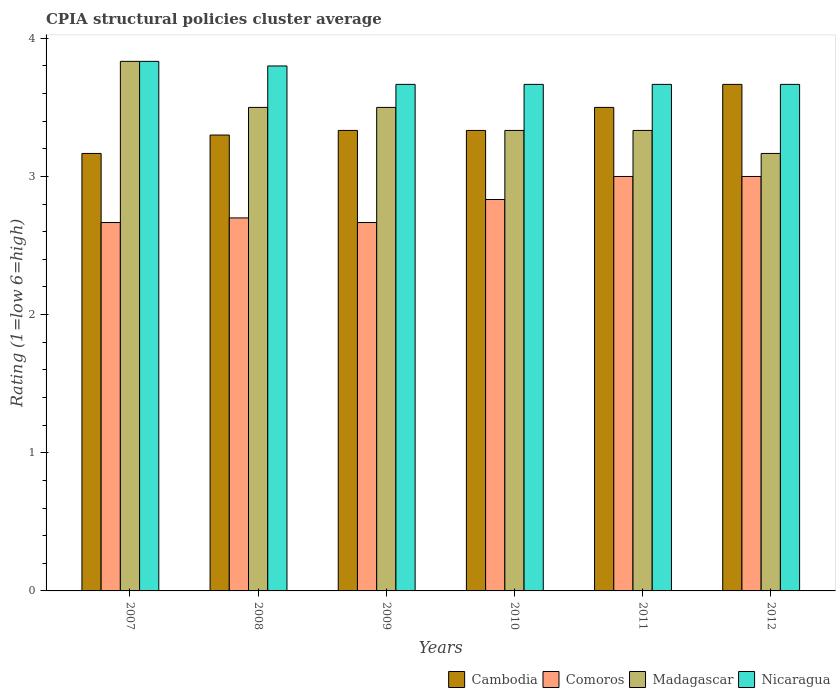How many different coloured bars are there?
Provide a succinct answer. 4. How many groups of bars are there?
Your answer should be compact. 6. Are the number of bars on each tick of the X-axis equal?
Your response must be concise. Yes. How many bars are there on the 6th tick from the left?
Provide a short and direct response. 4. What is the CPIA rating in Comoros in 2008?
Your response must be concise. 2.7. Across all years, what is the maximum CPIA rating in Cambodia?
Provide a succinct answer. 3.67. Across all years, what is the minimum CPIA rating in Nicaragua?
Provide a succinct answer. 3.67. In which year was the CPIA rating in Cambodia minimum?
Ensure brevity in your answer.  2007. What is the total CPIA rating in Nicaragua in the graph?
Offer a very short reply. 22.3. What is the difference between the CPIA rating in Cambodia in 2007 and that in 2010?
Offer a terse response. -0.17. What is the difference between the CPIA rating in Cambodia in 2011 and the CPIA rating in Madagascar in 2007?
Make the answer very short. -0.33. What is the average CPIA rating in Nicaragua per year?
Give a very brief answer. 3.72. In the year 2008, what is the difference between the CPIA rating in Madagascar and CPIA rating in Nicaragua?
Keep it short and to the point. -0.3. What is the ratio of the CPIA rating in Madagascar in 2009 to that in 2011?
Provide a short and direct response. 1.05. Is the CPIA rating in Comoros in 2008 less than that in 2012?
Offer a very short reply. Yes. In how many years, is the CPIA rating in Madagascar greater than the average CPIA rating in Madagascar taken over all years?
Provide a succinct answer. 3. Is it the case that in every year, the sum of the CPIA rating in Cambodia and CPIA rating in Nicaragua is greater than the sum of CPIA rating in Comoros and CPIA rating in Madagascar?
Your answer should be compact. No. What does the 1st bar from the left in 2008 represents?
Your response must be concise. Cambodia. What does the 3rd bar from the right in 2011 represents?
Offer a very short reply. Comoros. Are all the bars in the graph horizontal?
Offer a terse response. No. How many years are there in the graph?
Provide a succinct answer. 6. What is the difference between two consecutive major ticks on the Y-axis?
Keep it short and to the point. 1. Are the values on the major ticks of Y-axis written in scientific E-notation?
Offer a terse response. No. Does the graph contain any zero values?
Provide a succinct answer. No. Does the graph contain grids?
Your answer should be very brief. No. What is the title of the graph?
Provide a short and direct response. CPIA structural policies cluster average. Does "Comoros" appear as one of the legend labels in the graph?
Make the answer very short. Yes. What is the Rating (1=low 6=high) in Cambodia in 2007?
Your answer should be compact. 3.17. What is the Rating (1=low 6=high) of Comoros in 2007?
Keep it short and to the point. 2.67. What is the Rating (1=low 6=high) of Madagascar in 2007?
Keep it short and to the point. 3.83. What is the Rating (1=low 6=high) in Nicaragua in 2007?
Your answer should be compact. 3.83. What is the Rating (1=low 6=high) in Cambodia in 2008?
Your answer should be compact. 3.3. What is the Rating (1=low 6=high) of Comoros in 2008?
Your response must be concise. 2.7. What is the Rating (1=low 6=high) of Nicaragua in 2008?
Offer a terse response. 3.8. What is the Rating (1=low 6=high) of Cambodia in 2009?
Ensure brevity in your answer.  3.33. What is the Rating (1=low 6=high) of Comoros in 2009?
Offer a very short reply. 2.67. What is the Rating (1=low 6=high) of Nicaragua in 2009?
Ensure brevity in your answer.  3.67. What is the Rating (1=low 6=high) of Cambodia in 2010?
Your response must be concise. 3.33. What is the Rating (1=low 6=high) in Comoros in 2010?
Offer a terse response. 2.83. What is the Rating (1=low 6=high) of Madagascar in 2010?
Give a very brief answer. 3.33. What is the Rating (1=low 6=high) in Nicaragua in 2010?
Keep it short and to the point. 3.67. What is the Rating (1=low 6=high) in Madagascar in 2011?
Provide a succinct answer. 3.33. What is the Rating (1=low 6=high) of Nicaragua in 2011?
Keep it short and to the point. 3.67. What is the Rating (1=low 6=high) in Cambodia in 2012?
Provide a succinct answer. 3.67. What is the Rating (1=low 6=high) of Comoros in 2012?
Your response must be concise. 3. What is the Rating (1=low 6=high) of Madagascar in 2012?
Provide a short and direct response. 3.17. What is the Rating (1=low 6=high) in Nicaragua in 2012?
Keep it short and to the point. 3.67. Across all years, what is the maximum Rating (1=low 6=high) of Cambodia?
Make the answer very short. 3.67. Across all years, what is the maximum Rating (1=low 6=high) in Madagascar?
Provide a succinct answer. 3.83. Across all years, what is the maximum Rating (1=low 6=high) in Nicaragua?
Your response must be concise. 3.83. Across all years, what is the minimum Rating (1=low 6=high) of Cambodia?
Your answer should be compact. 3.17. Across all years, what is the minimum Rating (1=low 6=high) of Comoros?
Keep it short and to the point. 2.67. Across all years, what is the minimum Rating (1=low 6=high) in Madagascar?
Provide a succinct answer. 3.17. Across all years, what is the minimum Rating (1=low 6=high) in Nicaragua?
Offer a very short reply. 3.67. What is the total Rating (1=low 6=high) in Cambodia in the graph?
Give a very brief answer. 20.3. What is the total Rating (1=low 6=high) of Comoros in the graph?
Give a very brief answer. 16.87. What is the total Rating (1=low 6=high) in Madagascar in the graph?
Provide a short and direct response. 20.67. What is the total Rating (1=low 6=high) of Nicaragua in the graph?
Give a very brief answer. 22.3. What is the difference between the Rating (1=low 6=high) in Cambodia in 2007 and that in 2008?
Your response must be concise. -0.13. What is the difference between the Rating (1=low 6=high) in Comoros in 2007 and that in 2008?
Offer a very short reply. -0.03. What is the difference between the Rating (1=low 6=high) in Nicaragua in 2007 and that in 2008?
Make the answer very short. 0.03. What is the difference between the Rating (1=low 6=high) in Comoros in 2007 and that in 2009?
Offer a terse response. 0. What is the difference between the Rating (1=low 6=high) in Cambodia in 2007 and that in 2011?
Offer a very short reply. -0.33. What is the difference between the Rating (1=low 6=high) of Nicaragua in 2007 and that in 2011?
Offer a terse response. 0.17. What is the difference between the Rating (1=low 6=high) in Comoros in 2007 and that in 2012?
Your answer should be very brief. -0.33. What is the difference between the Rating (1=low 6=high) in Madagascar in 2007 and that in 2012?
Offer a terse response. 0.67. What is the difference between the Rating (1=low 6=high) in Nicaragua in 2007 and that in 2012?
Your answer should be compact. 0.17. What is the difference between the Rating (1=low 6=high) of Cambodia in 2008 and that in 2009?
Give a very brief answer. -0.03. What is the difference between the Rating (1=low 6=high) in Madagascar in 2008 and that in 2009?
Your answer should be very brief. 0. What is the difference between the Rating (1=low 6=high) in Nicaragua in 2008 and that in 2009?
Offer a terse response. 0.13. What is the difference between the Rating (1=low 6=high) in Cambodia in 2008 and that in 2010?
Make the answer very short. -0.03. What is the difference between the Rating (1=low 6=high) in Comoros in 2008 and that in 2010?
Provide a succinct answer. -0.13. What is the difference between the Rating (1=low 6=high) in Nicaragua in 2008 and that in 2010?
Offer a terse response. 0.13. What is the difference between the Rating (1=low 6=high) in Madagascar in 2008 and that in 2011?
Provide a succinct answer. 0.17. What is the difference between the Rating (1=low 6=high) in Nicaragua in 2008 and that in 2011?
Your answer should be compact. 0.13. What is the difference between the Rating (1=low 6=high) in Cambodia in 2008 and that in 2012?
Offer a very short reply. -0.37. What is the difference between the Rating (1=low 6=high) of Comoros in 2008 and that in 2012?
Provide a short and direct response. -0.3. What is the difference between the Rating (1=low 6=high) of Nicaragua in 2008 and that in 2012?
Your answer should be very brief. 0.13. What is the difference between the Rating (1=low 6=high) of Nicaragua in 2009 and that in 2010?
Your response must be concise. 0. What is the difference between the Rating (1=low 6=high) in Nicaragua in 2009 and that in 2011?
Ensure brevity in your answer.  0. What is the difference between the Rating (1=low 6=high) in Cambodia in 2009 and that in 2012?
Keep it short and to the point. -0.33. What is the difference between the Rating (1=low 6=high) in Comoros in 2009 and that in 2012?
Your answer should be very brief. -0.33. What is the difference between the Rating (1=low 6=high) of Madagascar in 2009 and that in 2012?
Offer a terse response. 0.33. What is the difference between the Rating (1=low 6=high) of Nicaragua in 2009 and that in 2012?
Ensure brevity in your answer.  0. What is the difference between the Rating (1=low 6=high) in Comoros in 2010 and that in 2011?
Provide a short and direct response. -0.17. What is the difference between the Rating (1=low 6=high) in Nicaragua in 2010 and that in 2011?
Offer a very short reply. 0. What is the difference between the Rating (1=low 6=high) of Cambodia in 2010 and that in 2012?
Provide a short and direct response. -0.33. What is the difference between the Rating (1=low 6=high) of Comoros in 2010 and that in 2012?
Provide a short and direct response. -0.17. What is the difference between the Rating (1=low 6=high) of Cambodia in 2011 and that in 2012?
Offer a very short reply. -0.17. What is the difference between the Rating (1=low 6=high) of Comoros in 2011 and that in 2012?
Provide a succinct answer. 0. What is the difference between the Rating (1=low 6=high) of Cambodia in 2007 and the Rating (1=low 6=high) of Comoros in 2008?
Provide a succinct answer. 0.47. What is the difference between the Rating (1=low 6=high) of Cambodia in 2007 and the Rating (1=low 6=high) of Nicaragua in 2008?
Your answer should be compact. -0.63. What is the difference between the Rating (1=low 6=high) in Comoros in 2007 and the Rating (1=low 6=high) in Nicaragua in 2008?
Give a very brief answer. -1.13. What is the difference between the Rating (1=low 6=high) in Madagascar in 2007 and the Rating (1=low 6=high) in Nicaragua in 2008?
Give a very brief answer. 0.03. What is the difference between the Rating (1=low 6=high) in Cambodia in 2007 and the Rating (1=low 6=high) in Comoros in 2009?
Offer a very short reply. 0.5. What is the difference between the Rating (1=low 6=high) of Cambodia in 2007 and the Rating (1=low 6=high) of Madagascar in 2009?
Ensure brevity in your answer.  -0.33. What is the difference between the Rating (1=low 6=high) of Cambodia in 2007 and the Rating (1=low 6=high) of Nicaragua in 2009?
Offer a terse response. -0.5. What is the difference between the Rating (1=low 6=high) in Madagascar in 2007 and the Rating (1=low 6=high) in Nicaragua in 2009?
Your answer should be very brief. 0.17. What is the difference between the Rating (1=low 6=high) in Cambodia in 2007 and the Rating (1=low 6=high) in Nicaragua in 2010?
Provide a short and direct response. -0.5. What is the difference between the Rating (1=low 6=high) in Comoros in 2007 and the Rating (1=low 6=high) in Madagascar in 2010?
Your response must be concise. -0.67. What is the difference between the Rating (1=low 6=high) of Comoros in 2007 and the Rating (1=low 6=high) of Nicaragua in 2010?
Offer a terse response. -1. What is the difference between the Rating (1=low 6=high) of Cambodia in 2007 and the Rating (1=low 6=high) of Nicaragua in 2011?
Your answer should be very brief. -0.5. What is the difference between the Rating (1=low 6=high) in Comoros in 2007 and the Rating (1=low 6=high) in Madagascar in 2011?
Offer a very short reply. -0.67. What is the difference between the Rating (1=low 6=high) in Cambodia in 2007 and the Rating (1=low 6=high) in Nicaragua in 2012?
Provide a succinct answer. -0.5. What is the difference between the Rating (1=low 6=high) in Comoros in 2007 and the Rating (1=low 6=high) in Nicaragua in 2012?
Your answer should be compact. -1. What is the difference between the Rating (1=low 6=high) of Cambodia in 2008 and the Rating (1=low 6=high) of Comoros in 2009?
Make the answer very short. 0.63. What is the difference between the Rating (1=low 6=high) of Cambodia in 2008 and the Rating (1=low 6=high) of Nicaragua in 2009?
Offer a very short reply. -0.37. What is the difference between the Rating (1=low 6=high) of Comoros in 2008 and the Rating (1=low 6=high) of Nicaragua in 2009?
Give a very brief answer. -0.97. What is the difference between the Rating (1=low 6=high) of Madagascar in 2008 and the Rating (1=low 6=high) of Nicaragua in 2009?
Your answer should be very brief. -0.17. What is the difference between the Rating (1=low 6=high) in Cambodia in 2008 and the Rating (1=low 6=high) in Comoros in 2010?
Your answer should be compact. 0.47. What is the difference between the Rating (1=low 6=high) of Cambodia in 2008 and the Rating (1=low 6=high) of Madagascar in 2010?
Your answer should be compact. -0.03. What is the difference between the Rating (1=low 6=high) in Cambodia in 2008 and the Rating (1=low 6=high) in Nicaragua in 2010?
Offer a terse response. -0.37. What is the difference between the Rating (1=low 6=high) of Comoros in 2008 and the Rating (1=low 6=high) of Madagascar in 2010?
Provide a short and direct response. -0.63. What is the difference between the Rating (1=low 6=high) of Comoros in 2008 and the Rating (1=low 6=high) of Nicaragua in 2010?
Provide a succinct answer. -0.97. What is the difference between the Rating (1=low 6=high) in Madagascar in 2008 and the Rating (1=low 6=high) in Nicaragua in 2010?
Provide a succinct answer. -0.17. What is the difference between the Rating (1=low 6=high) of Cambodia in 2008 and the Rating (1=low 6=high) of Madagascar in 2011?
Your answer should be very brief. -0.03. What is the difference between the Rating (1=low 6=high) in Cambodia in 2008 and the Rating (1=low 6=high) in Nicaragua in 2011?
Provide a succinct answer. -0.37. What is the difference between the Rating (1=low 6=high) in Comoros in 2008 and the Rating (1=low 6=high) in Madagascar in 2011?
Your response must be concise. -0.63. What is the difference between the Rating (1=low 6=high) of Comoros in 2008 and the Rating (1=low 6=high) of Nicaragua in 2011?
Ensure brevity in your answer.  -0.97. What is the difference between the Rating (1=low 6=high) of Madagascar in 2008 and the Rating (1=low 6=high) of Nicaragua in 2011?
Your answer should be very brief. -0.17. What is the difference between the Rating (1=low 6=high) in Cambodia in 2008 and the Rating (1=low 6=high) in Comoros in 2012?
Offer a terse response. 0.3. What is the difference between the Rating (1=low 6=high) in Cambodia in 2008 and the Rating (1=low 6=high) in Madagascar in 2012?
Your response must be concise. 0.13. What is the difference between the Rating (1=low 6=high) in Cambodia in 2008 and the Rating (1=low 6=high) in Nicaragua in 2012?
Provide a succinct answer. -0.37. What is the difference between the Rating (1=low 6=high) in Comoros in 2008 and the Rating (1=low 6=high) in Madagascar in 2012?
Keep it short and to the point. -0.47. What is the difference between the Rating (1=low 6=high) in Comoros in 2008 and the Rating (1=low 6=high) in Nicaragua in 2012?
Your answer should be very brief. -0.97. What is the difference between the Rating (1=low 6=high) of Madagascar in 2008 and the Rating (1=low 6=high) of Nicaragua in 2012?
Provide a succinct answer. -0.17. What is the difference between the Rating (1=low 6=high) in Cambodia in 2009 and the Rating (1=low 6=high) in Comoros in 2010?
Ensure brevity in your answer.  0.5. What is the difference between the Rating (1=low 6=high) of Comoros in 2009 and the Rating (1=low 6=high) of Nicaragua in 2010?
Offer a terse response. -1. What is the difference between the Rating (1=low 6=high) of Madagascar in 2009 and the Rating (1=low 6=high) of Nicaragua in 2010?
Ensure brevity in your answer.  -0.17. What is the difference between the Rating (1=low 6=high) in Cambodia in 2009 and the Rating (1=low 6=high) in Comoros in 2011?
Make the answer very short. 0.33. What is the difference between the Rating (1=low 6=high) in Cambodia in 2009 and the Rating (1=low 6=high) in Nicaragua in 2011?
Ensure brevity in your answer.  -0.33. What is the difference between the Rating (1=low 6=high) in Comoros in 2009 and the Rating (1=low 6=high) in Madagascar in 2011?
Provide a short and direct response. -0.67. What is the difference between the Rating (1=low 6=high) in Comoros in 2009 and the Rating (1=low 6=high) in Nicaragua in 2011?
Offer a very short reply. -1. What is the difference between the Rating (1=low 6=high) in Cambodia in 2009 and the Rating (1=low 6=high) in Comoros in 2012?
Make the answer very short. 0.33. What is the difference between the Rating (1=low 6=high) in Cambodia in 2009 and the Rating (1=low 6=high) in Nicaragua in 2012?
Ensure brevity in your answer.  -0.33. What is the difference between the Rating (1=low 6=high) in Cambodia in 2010 and the Rating (1=low 6=high) in Nicaragua in 2011?
Your answer should be compact. -0.33. What is the difference between the Rating (1=low 6=high) of Comoros in 2010 and the Rating (1=low 6=high) of Madagascar in 2011?
Keep it short and to the point. -0.5. What is the difference between the Rating (1=low 6=high) in Comoros in 2010 and the Rating (1=low 6=high) in Nicaragua in 2011?
Your answer should be compact. -0.83. What is the difference between the Rating (1=low 6=high) of Cambodia in 2010 and the Rating (1=low 6=high) of Madagascar in 2012?
Your answer should be very brief. 0.17. What is the difference between the Rating (1=low 6=high) in Comoros in 2010 and the Rating (1=low 6=high) in Madagascar in 2012?
Give a very brief answer. -0.33. What is the difference between the Rating (1=low 6=high) of Comoros in 2010 and the Rating (1=low 6=high) of Nicaragua in 2012?
Keep it short and to the point. -0.83. What is the difference between the Rating (1=low 6=high) of Cambodia in 2011 and the Rating (1=low 6=high) of Madagascar in 2012?
Provide a succinct answer. 0.33. What is the difference between the Rating (1=low 6=high) of Cambodia in 2011 and the Rating (1=low 6=high) of Nicaragua in 2012?
Keep it short and to the point. -0.17. What is the difference between the Rating (1=low 6=high) of Comoros in 2011 and the Rating (1=low 6=high) of Madagascar in 2012?
Make the answer very short. -0.17. What is the difference between the Rating (1=low 6=high) of Comoros in 2011 and the Rating (1=low 6=high) of Nicaragua in 2012?
Offer a very short reply. -0.67. What is the difference between the Rating (1=low 6=high) in Madagascar in 2011 and the Rating (1=low 6=high) in Nicaragua in 2012?
Offer a very short reply. -0.33. What is the average Rating (1=low 6=high) of Cambodia per year?
Give a very brief answer. 3.38. What is the average Rating (1=low 6=high) of Comoros per year?
Give a very brief answer. 2.81. What is the average Rating (1=low 6=high) in Madagascar per year?
Offer a terse response. 3.44. What is the average Rating (1=low 6=high) of Nicaragua per year?
Provide a succinct answer. 3.72. In the year 2007, what is the difference between the Rating (1=low 6=high) of Cambodia and Rating (1=low 6=high) of Comoros?
Offer a very short reply. 0.5. In the year 2007, what is the difference between the Rating (1=low 6=high) in Cambodia and Rating (1=low 6=high) in Madagascar?
Ensure brevity in your answer.  -0.67. In the year 2007, what is the difference between the Rating (1=low 6=high) of Comoros and Rating (1=low 6=high) of Madagascar?
Your response must be concise. -1.17. In the year 2007, what is the difference between the Rating (1=low 6=high) of Comoros and Rating (1=low 6=high) of Nicaragua?
Offer a very short reply. -1.17. In the year 2008, what is the difference between the Rating (1=low 6=high) in Cambodia and Rating (1=low 6=high) in Comoros?
Your answer should be compact. 0.6. In the year 2008, what is the difference between the Rating (1=low 6=high) in Cambodia and Rating (1=low 6=high) in Madagascar?
Make the answer very short. -0.2. In the year 2008, what is the difference between the Rating (1=low 6=high) of Madagascar and Rating (1=low 6=high) of Nicaragua?
Make the answer very short. -0.3. In the year 2009, what is the difference between the Rating (1=low 6=high) of Cambodia and Rating (1=low 6=high) of Madagascar?
Keep it short and to the point. -0.17. In the year 2009, what is the difference between the Rating (1=low 6=high) of Comoros and Rating (1=low 6=high) of Madagascar?
Provide a short and direct response. -0.83. In the year 2010, what is the difference between the Rating (1=low 6=high) of Cambodia and Rating (1=low 6=high) of Comoros?
Provide a short and direct response. 0.5. In the year 2010, what is the difference between the Rating (1=low 6=high) in Cambodia and Rating (1=low 6=high) in Madagascar?
Ensure brevity in your answer.  0. In the year 2010, what is the difference between the Rating (1=low 6=high) of Cambodia and Rating (1=low 6=high) of Nicaragua?
Offer a very short reply. -0.33. In the year 2011, what is the difference between the Rating (1=low 6=high) of Cambodia and Rating (1=low 6=high) of Comoros?
Offer a terse response. 0.5. In the year 2011, what is the difference between the Rating (1=low 6=high) of Cambodia and Rating (1=low 6=high) of Madagascar?
Give a very brief answer. 0.17. In the year 2011, what is the difference between the Rating (1=low 6=high) in Comoros and Rating (1=low 6=high) in Madagascar?
Keep it short and to the point. -0.33. In the year 2011, what is the difference between the Rating (1=low 6=high) of Comoros and Rating (1=low 6=high) of Nicaragua?
Ensure brevity in your answer.  -0.67. In the year 2012, what is the difference between the Rating (1=low 6=high) in Cambodia and Rating (1=low 6=high) in Madagascar?
Offer a very short reply. 0.5. In the year 2012, what is the difference between the Rating (1=low 6=high) of Cambodia and Rating (1=low 6=high) of Nicaragua?
Offer a terse response. 0. What is the ratio of the Rating (1=low 6=high) in Cambodia in 2007 to that in 2008?
Your answer should be very brief. 0.96. What is the ratio of the Rating (1=low 6=high) in Comoros in 2007 to that in 2008?
Offer a terse response. 0.99. What is the ratio of the Rating (1=low 6=high) of Madagascar in 2007 to that in 2008?
Your response must be concise. 1.1. What is the ratio of the Rating (1=low 6=high) in Nicaragua in 2007 to that in 2008?
Offer a very short reply. 1.01. What is the ratio of the Rating (1=low 6=high) in Cambodia in 2007 to that in 2009?
Keep it short and to the point. 0.95. What is the ratio of the Rating (1=low 6=high) in Comoros in 2007 to that in 2009?
Your answer should be compact. 1. What is the ratio of the Rating (1=low 6=high) of Madagascar in 2007 to that in 2009?
Provide a short and direct response. 1.1. What is the ratio of the Rating (1=low 6=high) in Nicaragua in 2007 to that in 2009?
Give a very brief answer. 1.05. What is the ratio of the Rating (1=low 6=high) of Cambodia in 2007 to that in 2010?
Your response must be concise. 0.95. What is the ratio of the Rating (1=low 6=high) in Comoros in 2007 to that in 2010?
Ensure brevity in your answer.  0.94. What is the ratio of the Rating (1=low 6=high) in Madagascar in 2007 to that in 2010?
Make the answer very short. 1.15. What is the ratio of the Rating (1=low 6=high) of Nicaragua in 2007 to that in 2010?
Your answer should be very brief. 1.05. What is the ratio of the Rating (1=low 6=high) in Cambodia in 2007 to that in 2011?
Your answer should be compact. 0.9. What is the ratio of the Rating (1=low 6=high) of Madagascar in 2007 to that in 2011?
Keep it short and to the point. 1.15. What is the ratio of the Rating (1=low 6=high) in Nicaragua in 2007 to that in 2011?
Provide a succinct answer. 1.05. What is the ratio of the Rating (1=low 6=high) in Cambodia in 2007 to that in 2012?
Ensure brevity in your answer.  0.86. What is the ratio of the Rating (1=low 6=high) in Comoros in 2007 to that in 2012?
Keep it short and to the point. 0.89. What is the ratio of the Rating (1=low 6=high) in Madagascar in 2007 to that in 2012?
Keep it short and to the point. 1.21. What is the ratio of the Rating (1=low 6=high) in Nicaragua in 2007 to that in 2012?
Make the answer very short. 1.05. What is the ratio of the Rating (1=low 6=high) of Cambodia in 2008 to that in 2009?
Provide a succinct answer. 0.99. What is the ratio of the Rating (1=low 6=high) in Comoros in 2008 to that in 2009?
Your answer should be compact. 1.01. What is the ratio of the Rating (1=low 6=high) of Madagascar in 2008 to that in 2009?
Provide a short and direct response. 1. What is the ratio of the Rating (1=low 6=high) of Nicaragua in 2008 to that in 2009?
Give a very brief answer. 1.04. What is the ratio of the Rating (1=low 6=high) of Comoros in 2008 to that in 2010?
Ensure brevity in your answer.  0.95. What is the ratio of the Rating (1=low 6=high) in Nicaragua in 2008 to that in 2010?
Your answer should be compact. 1.04. What is the ratio of the Rating (1=low 6=high) in Cambodia in 2008 to that in 2011?
Your answer should be very brief. 0.94. What is the ratio of the Rating (1=low 6=high) in Comoros in 2008 to that in 2011?
Offer a terse response. 0.9. What is the ratio of the Rating (1=low 6=high) in Nicaragua in 2008 to that in 2011?
Make the answer very short. 1.04. What is the ratio of the Rating (1=low 6=high) of Madagascar in 2008 to that in 2012?
Provide a short and direct response. 1.11. What is the ratio of the Rating (1=low 6=high) of Nicaragua in 2008 to that in 2012?
Your answer should be compact. 1.04. What is the ratio of the Rating (1=low 6=high) in Nicaragua in 2009 to that in 2010?
Offer a very short reply. 1. What is the ratio of the Rating (1=low 6=high) in Cambodia in 2009 to that in 2011?
Keep it short and to the point. 0.95. What is the ratio of the Rating (1=low 6=high) in Comoros in 2009 to that in 2012?
Offer a terse response. 0.89. What is the ratio of the Rating (1=low 6=high) in Madagascar in 2009 to that in 2012?
Your answer should be compact. 1.11. What is the ratio of the Rating (1=low 6=high) of Nicaragua in 2009 to that in 2012?
Provide a succinct answer. 1. What is the ratio of the Rating (1=low 6=high) of Cambodia in 2010 to that in 2012?
Your answer should be compact. 0.91. What is the ratio of the Rating (1=low 6=high) of Madagascar in 2010 to that in 2012?
Keep it short and to the point. 1.05. What is the ratio of the Rating (1=low 6=high) of Cambodia in 2011 to that in 2012?
Your answer should be very brief. 0.95. What is the ratio of the Rating (1=low 6=high) in Comoros in 2011 to that in 2012?
Your response must be concise. 1. What is the ratio of the Rating (1=low 6=high) in Madagascar in 2011 to that in 2012?
Your response must be concise. 1.05. What is the difference between the highest and the second highest Rating (1=low 6=high) in Cambodia?
Ensure brevity in your answer.  0.17. What is the difference between the highest and the second highest Rating (1=low 6=high) in Comoros?
Provide a succinct answer. 0. What is the difference between the highest and the second highest Rating (1=low 6=high) of Nicaragua?
Give a very brief answer. 0.03. What is the difference between the highest and the lowest Rating (1=low 6=high) in Nicaragua?
Offer a terse response. 0.17. 